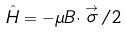Convert formula to latex. <formula><loc_0><loc_0><loc_500><loc_500>\hat { H } = - \mu { B } \cdot \stackrel { \rightarrow } { \sigma } / 2</formula> 